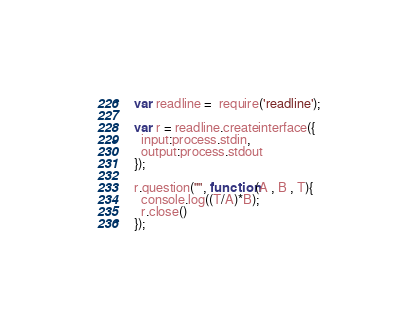Convert code to text. <code><loc_0><loc_0><loc_500><loc_500><_JavaScript_>var readline =  require('readline');

var r = readline.createinterface({
  input:process.stdin,
  output:process.stdout
});

r.question("", function(A , B , T){
  console.log((T/A)*B);
  r.close()
});</code> 